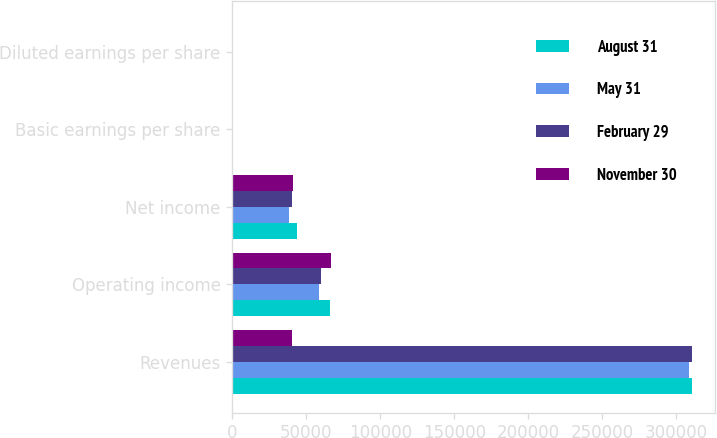Convert chart to OTSL. <chart><loc_0><loc_0><loc_500><loc_500><stacked_bar_chart><ecel><fcel>Revenues<fcel>Operating income<fcel>Net income<fcel>Basic earnings per share<fcel>Diluted earnings per share<nl><fcel>August 31<fcel>310980<fcel>66232<fcel>43575<fcel>0.54<fcel>0.53<nl><fcel>May 31<fcel>308776<fcel>58431<fcel>38313<fcel>0.48<fcel>0.48<nl><fcel>February 29<fcel>310641<fcel>59911<fcel>40055<fcel>0.51<fcel>0.5<nl><fcel>November 30<fcel>40055<fcel>66785<fcel>40811<fcel>0.51<fcel>0.5<nl></chart> 